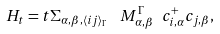Convert formula to latex. <formula><loc_0><loc_0><loc_500><loc_500>H _ { t } = t \Sigma _ { \alpha , \beta , \langle i j \rangle _ { \Gamma } } \ \ M ^ { \Gamma } _ { \alpha , \beta } \ c ^ { + } _ { i , \alpha } c _ { j , \beta } ,</formula> 